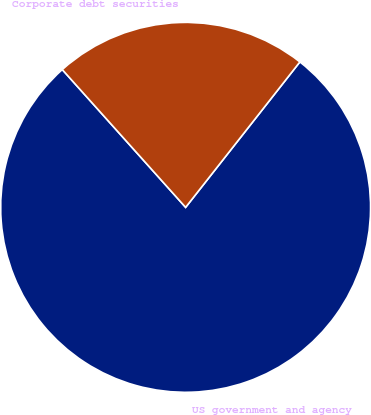Convert chart. <chart><loc_0><loc_0><loc_500><loc_500><pie_chart><fcel>US government and agency<fcel>Corporate debt securities<nl><fcel>77.78%<fcel>22.22%<nl></chart> 